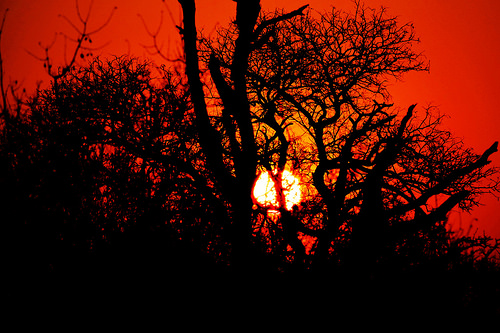<image>
Can you confirm if the sun is in front of the trees? No. The sun is not in front of the trees. The spatial positioning shows a different relationship between these objects. 